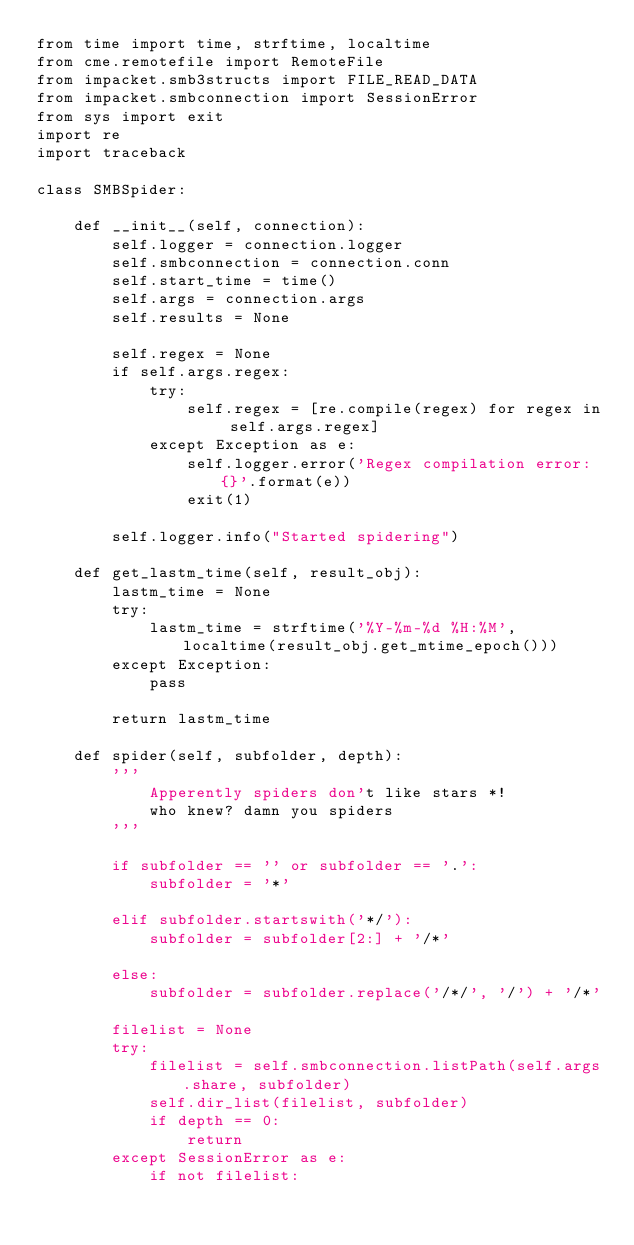<code> <loc_0><loc_0><loc_500><loc_500><_Python_>from time import time, strftime, localtime
from cme.remotefile import RemoteFile
from impacket.smb3structs import FILE_READ_DATA
from impacket.smbconnection import SessionError
from sys import exit
import re
import traceback

class SMBSpider:

    def __init__(self, connection):
        self.logger = connection.logger
        self.smbconnection = connection.conn
        self.start_time = time()
        self.args = connection.args
        self.results = None

        self.regex = None
        if self.args.regex:
            try:
                self.regex = [re.compile(regex) for regex in self.args.regex]
            except Exception as e:
                self.logger.error('Regex compilation error: {}'.format(e))
                exit(1)

        self.logger.info("Started spidering")

    def get_lastm_time(self, result_obj):
        lastm_time = None
        try:
            lastm_time = strftime('%Y-%m-%d %H:%M', localtime(result_obj.get_mtime_epoch()))
        except Exception:
            pass

        return lastm_time

    def spider(self, subfolder, depth):
        '''
            Apperently spiders don't like stars *!
            who knew? damn you spiders
        '''

        if subfolder == '' or subfolder == '.':
            subfolder = '*'

        elif subfolder.startswith('*/'):
            subfolder = subfolder[2:] + '/*'

        else:
            subfolder = subfolder.replace('/*/', '/') + '/*'

        filelist = None
        try:
            filelist = self.smbconnection.listPath(self.args.share, subfolder)
            self.dir_list(filelist, subfolder)
            if depth == 0:
                return
        except SessionError as e:
            if not filelist:</code> 